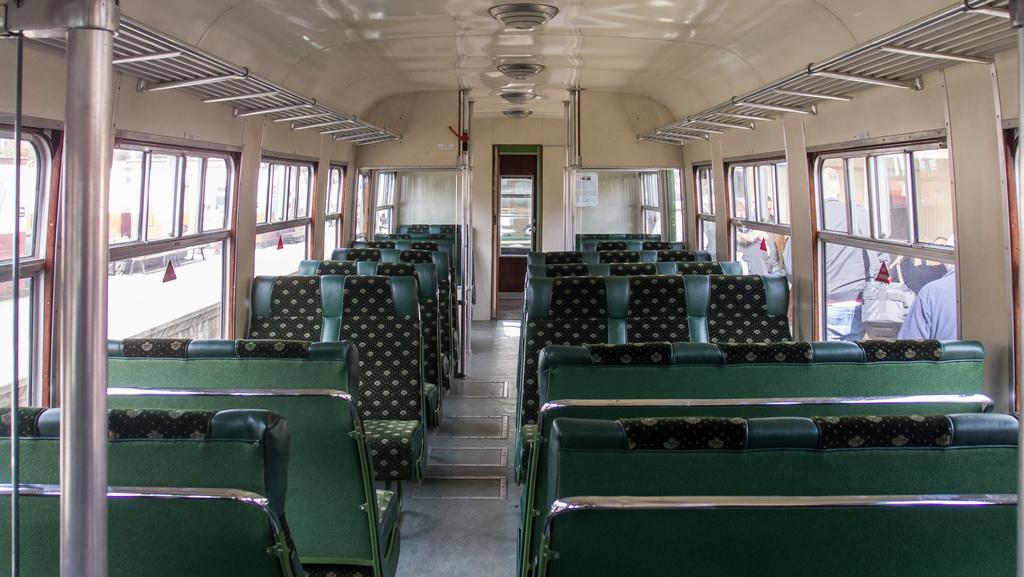Describe this image in one or two sentences. This is an inside view of a bus and here we can see rods, seats, windows, a poster and some lights, through the glass, we can see some people and some objects. 